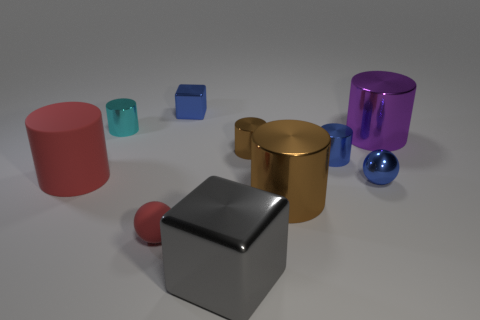Subtract all tiny brown metal cylinders. How many cylinders are left? 5 Subtract 1 cylinders. How many cylinders are left? 5 Subtract all blue balls. How many balls are left? 1 Subtract all balls. How many objects are left? 8 Subtract all gray spheres. How many brown cylinders are left? 2 Subtract all tiny blue spheres. Subtract all big brown rubber cylinders. How many objects are left? 9 Add 4 blue objects. How many blue objects are left? 7 Add 2 large brown matte balls. How many large brown matte balls exist? 2 Subtract 1 blue balls. How many objects are left? 9 Subtract all cyan cubes. Subtract all cyan cylinders. How many cubes are left? 2 